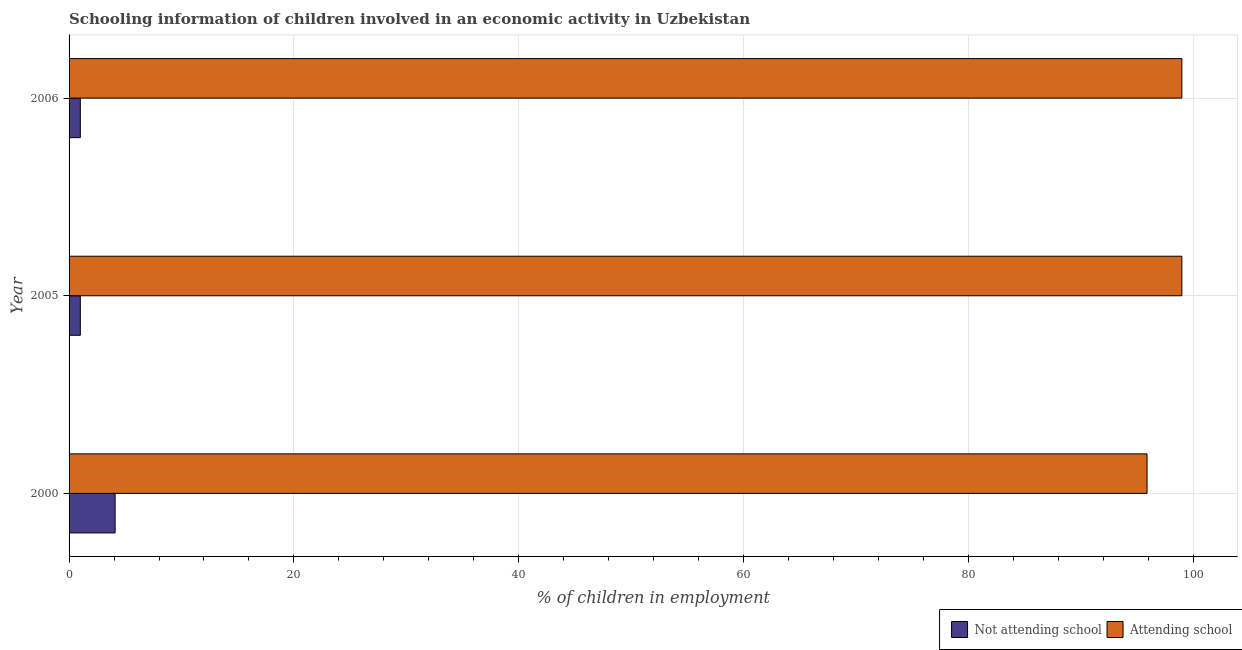How many bars are there on the 1st tick from the top?
Ensure brevity in your answer.  2. What is the percentage of employed children who are not attending school in 2005?
Your answer should be compact. 1. Across all years, what is the minimum percentage of employed children who are attending school?
Make the answer very short. 95.9. What is the total percentage of employed children who are not attending school in the graph?
Keep it short and to the point. 6.1. What is the difference between the percentage of employed children who are not attending school in 2005 and the percentage of employed children who are attending school in 2006?
Give a very brief answer. -98. What is the average percentage of employed children who are not attending school per year?
Your answer should be very brief. 2.03. In the year 2000, what is the difference between the percentage of employed children who are attending school and percentage of employed children who are not attending school?
Provide a short and direct response. 91.81. Is the difference between the percentage of employed children who are not attending school in 2005 and 2006 greater than the difference between the percentage of employed children who are attending school in 2005 and 2006?
Offer a terse response. No. What is the difference between the highest and the lowest percentage of employed children who are not attending school?
Ensure brevity in your answer.  3.1. What does the 2nd bar from the top in 2000 represents?
Your answer should be compact. Not attending school. What does the 2nd bar from the bottom in 2000 represents?
Offer a terse response. Attending school. How many bars are there?
Provide a short and direct response. 6. How many years are there in the graph?
Provide a short and direct response. 3. What is the difference between two consecutive major ticks on the X-axis?
Provide a short and direct response. 20. Does the graph contain any zero values?
Provide a succinct answer. No. Does the graph contain grids?
Give a very brief answer. Yes. Where does the legend appear in the graph?
Your answer should be compact. Bottom right. How are the legend labels stacked?
Your response must be concise. Horizontal. What is the title of the graph?
Give a very brief answer. Schooling information of children involved in an economic activity in Uzbekistan. What is the label or title of the X-axis?
Give a very brief answer. % of children in employment. What is the % of children in employment of Not attending school in 2000?
Offer a terse response. 4.1. What is the % of children in employment in Attending school in 2000?
Your answer should be very brief. 95.9. What is the % of children in employment in Not attending school in 2005?
Offer a very short reply. 1. What is the % of children in employment in Attending school in 2005?
Ensure brevity in your answer.  99. What is the % of children in employment of Not attending school in 2006?
Provide a succinct answer. 1. What is the % of children in employment in Attending school in 2006?
Provide a succinct answer. 99. Across all years, what is the maximum % of children in employment of Not attending school?
Keep it short and to the point. 4.1. Across all years, what is the minimum % of children in employment in Attending school?
Provide a short and direct response. 95.9. What is the total % of children in employment in Not attending school in the graph?
Offer a very short reply. 6.1. What is the total % of children in employment of Attending school in the graph?
Keep it short and to the point. 293.9. What is the difference between the % of children in employment of Not attending school in 2000 and that in 2005?
Ensure brevity in your answer.  3.1. What is the difference between the % of children in employment in Attending school in 2000 and that in 2005?
Make the answer very short. -3.1. What is the difference between the % of children in employment in Not attending school in 2000 and that in 2006?
Offer a very short reply. 3.1. What is the difference between the % of children in employment in Attending school in 2000 and that in 2006?
Your response must be concise. -3.1. What is the difference between the % of children in employment in Not attending school in 2005 and that in 2006?
Offer a very short reply. 0. What is the difference between the % of children in employment in Not attending school in 2000 and the % of children in employment in Attending school in 2005?
Give a very brief answer. -94.9. What is the difference between the % of children in employment in Not attending school in 2000 and the % of children in employment in Attending school in 2006?
Your answer should be very brief. -94.9. What is the difference between the % of children in employment of Not attending school in 2005 and the % of children in employment of Attending school in 2006?
Your answer should be compact. -98. What is the average % of children in employment of Not attending school per year?
Offer a very short reply. 2.03. What is the average % of children in employment in Attending school per year?
Provide a short and direct response. 97.97. In the year 2000, what is the difference between the % of children in employment in Not attending school and % of children in employment in Attending school?
Ensure brevity in your answer.  -91.81. In the year 2005, what is the difference between the % of children in employment of Not attending school and % of children in employment of Attending school?
Make the answer very short. -98. In the year 2006, what is the difference between the % of children in employment of Not attending school and % of children in employment of Attending school?
Offer a very short reply. -98. What is the ratio of the % of children in employment in Not attending school in 2000 to that in 2005?
Your answer should be very brief. 4.1. What is the ratio of the % of children in employment of Attending school in 2000 to that in 2005?
Give a very brief answer. 0.97. What is the ratio of the % of children in employment of Not attending school in 2000 to that in 2006?
Provide a short and direct response. 4.1. What is the ratio of the % of children in employment in Attending school in 2000 to that in 2006?
Your answer should be compact. 0.97. What is the ratio of the % of children in employment of Attending school in 2005 to that in 2006?
Provide a short and direct response. 1. What is the difference between the highest and the second highest % of children in employment in Not attending school?
Keep it short and to the point. 3.1. What is the difference between the highest and the lowest % of children in employment of Not attending school?
Your answer should be very brief. 3.1. What is the difference between the highest and the lowest % of children in employment in Attending school?
Keep it short and to the point. 3.1. 